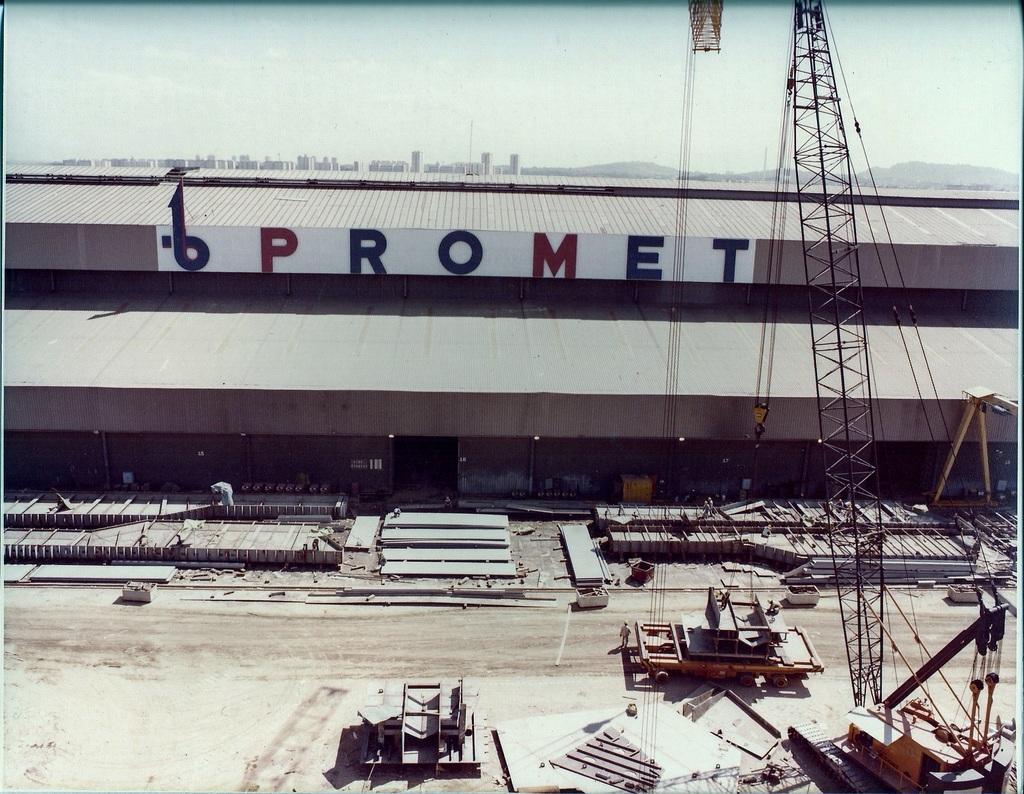How would you summarize this image in a sentence or two? In this image I can see vehicles and some other objects on the ground. Here I can see a building. Here I can see a name on the building. In the background I can see mountains and the sky. 